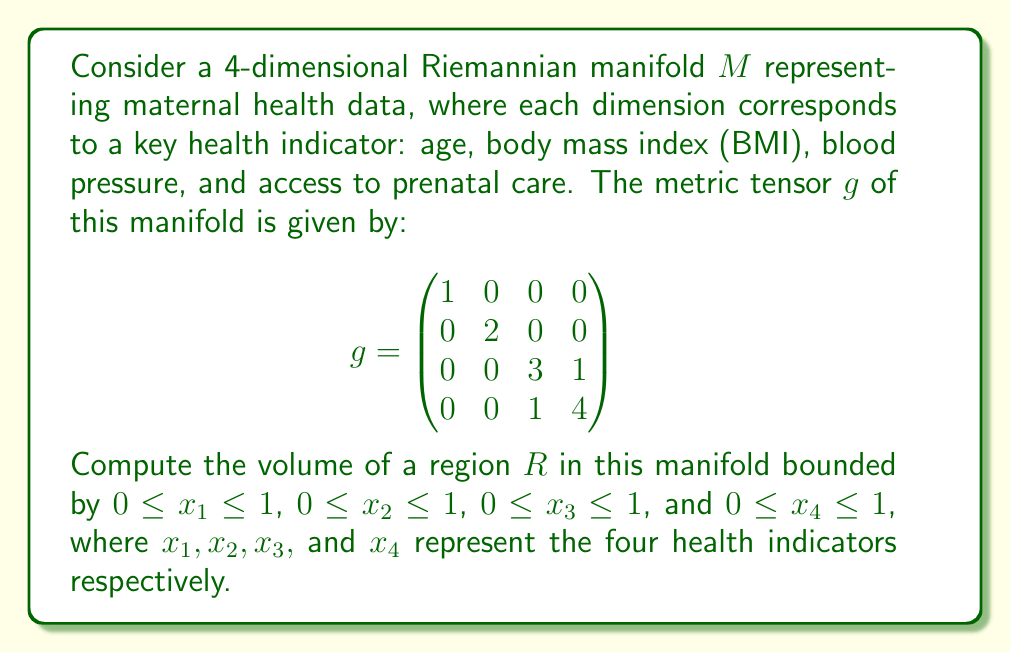Could you help me with this problem? To compute the volume of the region $R$ in the given 4-dimensional Riemannian manifold, we need to follow these steps:

1) The volume of a region in a Riemannian manifold is given by the integral:

   $$V = \int_R \sqrt{\det(g)} \, dx_1 \, dx_2 \, dx_3 \, dx_4$$

   where $\det(g)$ is the determinant of the metric tensor.

2) Let's calculate the determinant of $g$:

   $$\det(g) = \begin{vmatrix}
   1 & 0 & 0 & 0 \\
   0 & 2 & 0 & 0 \\
   0 & 0 & 3 & 1 \\
   0 & 0 & 1 & 4
   \end{vmatrix}$$

   $$\det(g) = 1 \cdot 2 \cdot (3 \cdot 4 - 1 \cdot 1) = 2 \cdot 11 = 22$$

3) Therefore, $\sqrt{\det(g)} = \sqrt{22}$

4) Now, we can set up our integral:

   $$V = \int_0^1 \int_0^1 \int_0^1 \int_0^1 \sqrt{22} \, dx_1 \, dx_2 \, dx_3 \, dx_4$$

5) Since $\sqrt{22}$ is constant with respect to all variables of integration, we can take it outside the integral:

   $$V = \sqrt{22} \int_0^1 \int_0^1 \int_0^1 \int_0^1 \, dx_1 \, dx_2 \, dx_3 \, dx_4$$

6) The remaining integral is simply the volume of a 4-dimensional unit cube, which is 1:

   $$V = \sqrt{22} \cdot 1 = \sqrt{22}$$

Thus, the volume of the region $R$ is $\sqrt{22}$ in the given manifold's units.
Answer: $\sqrt{22}$ units^4 